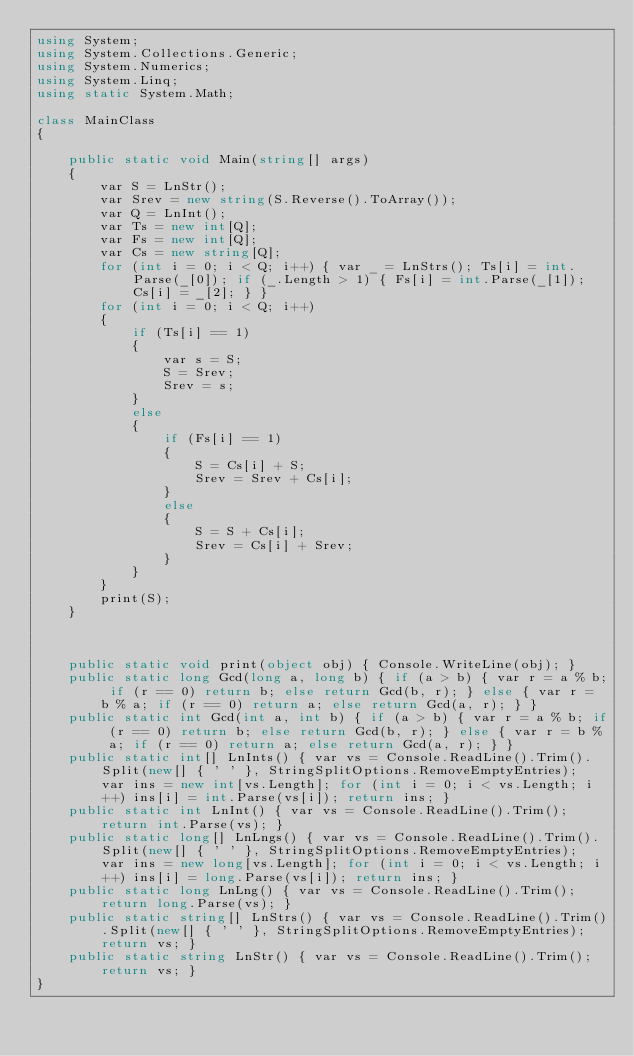<code> <loc_0><loc_0><loc_500><loc_500><_C#_>using System;
using System.Collections.Generic;
using System.Numerics;
using System.Linq;
using static System.Math;

class MainClass
{

    public static void Main(string[] args)
    {
        var S = LnStr();
        var Srev = new string(S.Reverse().ToArray());
        var Q = LnInt();
        var Ts = new int[Q];
        var Fs = new int[Q];
        var Cs = new string[Q];
        for (int i = 0; i < Q; i++) { var _ = LnStrs(); Ts[i] = int.Parse(_[0]); if (_.Length > 1) { Fs[i] = int.Parse(_[1]); Cs[i] = _[2]; } }
        for (int i = 0; i < Q; i++)
        {
            if (Ts[i] == 1)
            {
                var s = S;
                S = Srev;
                Srev = s;
            }
            else
            {
                if (Fs[i] == 1)
                {
                    S = Cs[i] + S;
                    Srev = Srev + Cs[i];
                }
                else
                {
                    S = S + Cs[i];
                    Srev = Cs[i] + Srev;
                }
            }
        }
        print(S);
    }



    public static void print(object obj) { Console.WriteLine(obj); }
    public static long Gcd(long a, long b) { if (a > b) { var r = a % b; if (r == 0) return b; else return Gcd(b, r); } else { var r = b % a; if (r == 0) return a; else return Gcd(a, r); } }
    public static int Gcd(int a, int b) { if (a > b) { var r = a % b; if (r == 0) return b; else return Gcd(b, r); } else { var r = b % a; if (r == 0) return a; else return Gcd(a, r); } }
    public static int[] LnInts() { var vs = Console.ReadLine().Trim().Split(new[] { ' ' }, StringSplitOptions.RemoveEmptyEntries); var ins = new int[vs.Length]; for (int i = 0; i < vs.Length; i++) ins[i] = int.Parse(vs[i]); return ins; }
    public static int LnInt() { var vs = Console.ReadLine().Trim(); return int.Parse(vs); }
    public static long[] LnLngs() { var vs = Console.ReadLine().Trim().Split(new[] { ' ' }, StringSplitOptions.RemoveEmptyEntries); var ins = new long[vs.Length]; for (int i = 0; i < vs.Length; i++) ins[i] = long.Parse(vs[i]); return ins; }
    public static long LnLng() { var vs = Console.ReadLine().Trim(); return long.Parse(vs); }
    public static string[] LnStrs() { var vs = Console.ReadLine().Trim().Split(new[] { ' ' }, StringSplitOptions.RemoveEmptyEntries); return vs; }
    public static string LnStr() { var vs = Console.ReadLine().Trim(); return vs; }
}

</code> 